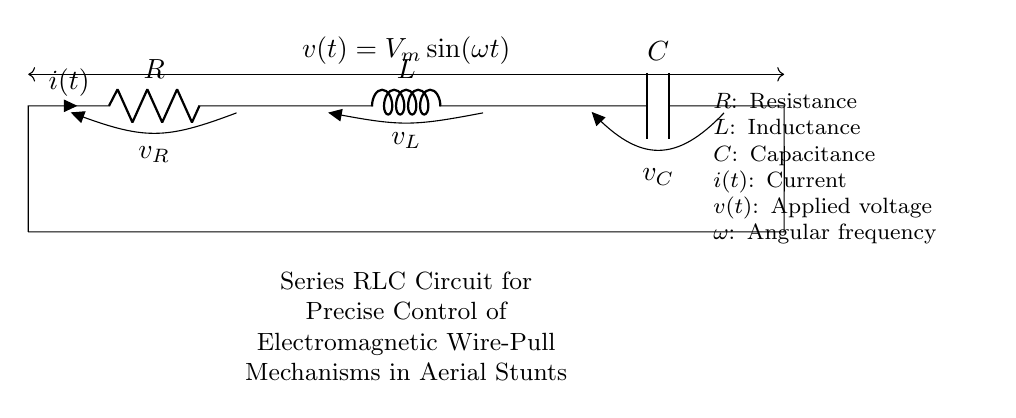What is the relationship between the resistance and the current in this circuit? The relationship between resistance and current in a circuit is described by Ohm's Law, which states that the voltage across a resistor is equal to the current flowing through it multiplied by the resistance (V = IR). In this circuit, the total current is influenced by the resistance value R.
Answer: Current dependency on resistance What are the main components in this RLC circuit? The main components in this RLC circuit are a resistor, an inductor, and a capacitor, each connected in series. The circuit diagram explicitly labels these components as R, L, and C.
Answer: Resistor, Inductor, Capacitor What describes the applied voltage in this circuit? The applied voltage in this circuit is represented as a sinusoidal function of time, denoted by v(t) = V_m * sin(ωt), where V_m is the maximum voltage and ω is the angular frequency. This signifies that the voltage oscillates over time.
Answer: Sinusoidal function What is the effect of increasing the inductance on the circuit behavior? Increasing the inductance L in a series RLC circuit tends to decrease the overall circuit current for a given applied voltage, since higher inductance opposes changes in current more significantly. This behavior alters the circuit's resonance characteristics and affects the timing of the response.
Answer: Decreased current What happens at resonance in a series RLC circuit? At resonance in a series RLC circuit, the reactance of the inductor (XL) and the reactance of the capacitor (XC) cancel each other out, resulting in a condition where the only opposition to the current is the resistance R. This leads to maximum current flow, and the circuit can efficiently transfer energy.
Answer: Maximum current flow 